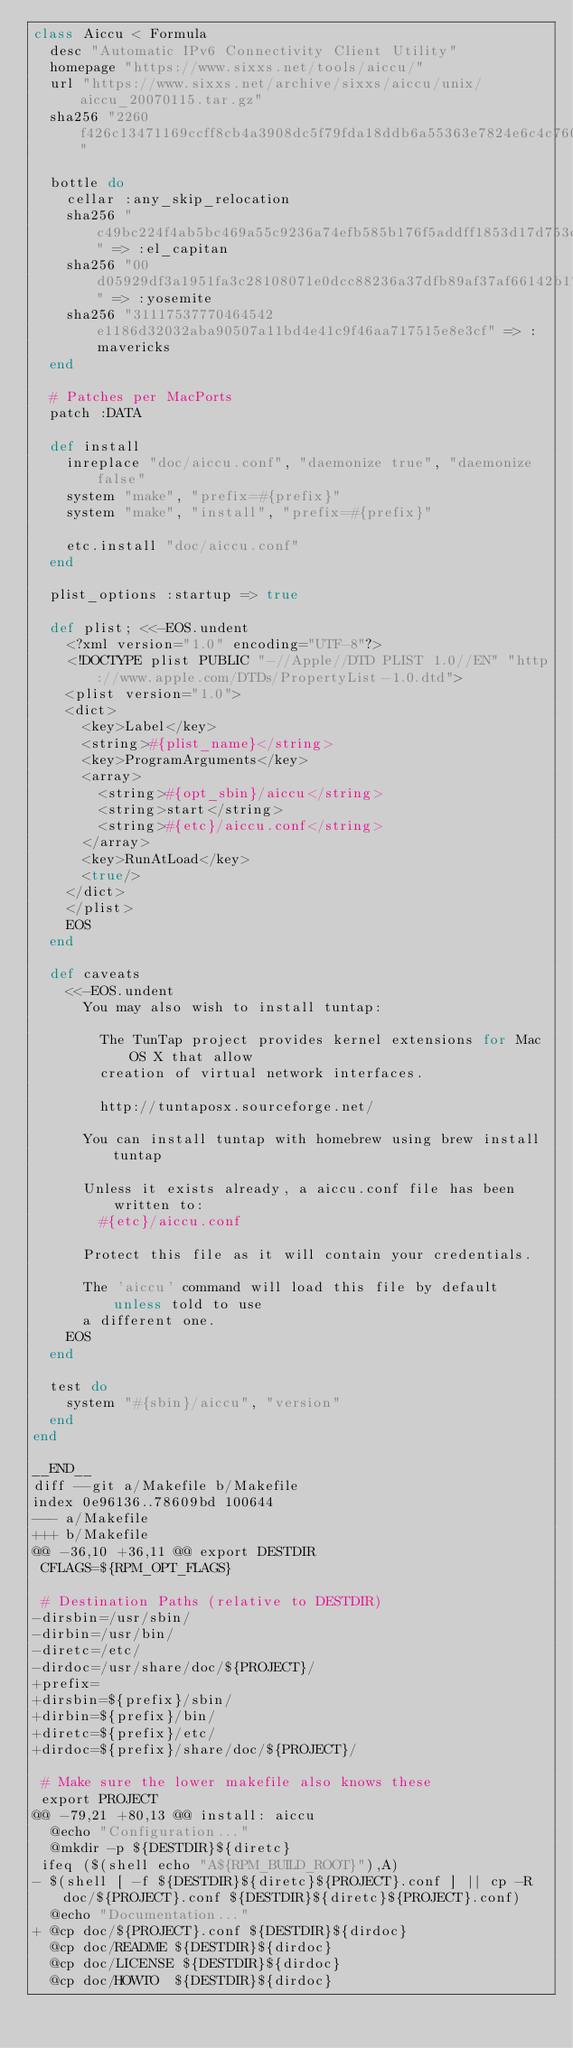<code> <loc_0><loc_0><loc_500><loc_500><_Ruby_>class Aiccu < Formula
  desc "Automatic IPv6 Connectivity Client Utility"
  homepage "https://www.sixxs.net/tools/aiccu/"
  url "https://www.sixxs.net/archive/sixxs/aiccu/unix/aiccu_20070115.tar.gz"
  sha256 "2260f426c13471169ccff8cb4a3908dc5f79fda18ddb6a55363e7824e6c4c760"

  bottle do
    cellar :any_skip_relocation
    sha256 "c49bc224f4ab5bc469a55c9236a74efb585b176f5addff1853d17d753cb3551c" => :el_capitan
    sha256 "00d05929df3a1951fa3c28108071e0dcc88236a37dfb89af37af66142b1746bf" => :yosemite
    sha256 "31117537770464542e1186d32032aba90507a11bd4e41c9f46aa717515e8e3cf" => :mavericks
  end

  # Patches per MacPorts
  patch :DATA

  def install
    inreplace "doc/aiccu.conf", "daemonize true", "daemonize false"
    system "make", "prefix=#{prefix}"
    system "make", "install", "prefix=#{prefix}"

    etc.install "doc/aiccu.conf"
  end

  plist_options :startup => true

  def plist; <<-EOS.undent
    <?xml version="1.0" encoding="UTF-8"?>
    <!DOCTYPE plist PUBLIC "-//Apple//DTD PLIST 1.0//EN" "http://www.apple.com/DTDs/PropertyList-1.0.dtd">
    <plist version="1.0">
    <dict>
      <key>Label</key>
      <string>#{plist_name}</string>
      <key>ProgramArguments</key>
      <array>
        <string>#{opt_sbin}/aiccu</string>
        <string>start</string>
        <string>#{etc}/aiccu.conf</string>
      </array>
      <key>RunAtLoad</key>
      <true/>
    </dict>
    </plist>
    EOS
  end

  def caveats
    <<-EOS.undent
      You may also wish to install tuntap:

        The TunTap project provides kernel extensions for Mac OS X that allow
        creation of virtual network interfaces.

        http://tuntaposx.sourceforge.net/

      You can install tuntap with homebrew using brew install tuntap

      Unless it exists already, a aiccu.conf file has been written to:
        #{etc}/aiccu.conf

      Protect this file as it will contain your credentials.

      The 'aiccu' command will load this file by default unless told to use
      a different one.
    EOS
  end

  test do
    system "#{sbin}/aiccu", "version"
  end
end

__END__
diff --git a/Makefile b/Makefile
index 0e96136..78609bd 100644
--- a/Makefile
+++ b/Makefile
@@ -36,10 +36,11 @@ export DESTDIR
 CFLAGS=${RPM_OPT_FLAGS}

 # Destination Paths (relative to DESTDIR)
-dirsbin=/usr/sbin/
-dirbin=/usr/bin/
-diretc=/etc/
-dirdoc=/usr/share/doc/${PROJECT}/
+prefix=
+dirsbin=${prefix}/sbin/
+dirbin=${prefix}/bin/
+diretc=${prefix}/etc/
+dirdoc=${prefix}/share/doc/${PROJECT}/

 # Make sure the lower makefile also knows these
 export PROJECT
@@ -79,21 +80,13 @@ install: aiccu
	@echo "Configuration..."
	@mkdir -p ${DESTDIR}${diretc}
 ifeq ($(shell echo "A${RPM_BUILD_ROOT}"),A)
-	$(shell [ -f ${DESTDIR}${diretc}${PROJECT}.conf ] || cp -R doc/${PROJECT}.conf ${DESTDIR}${diretc}${PROJECT}.conf)
	@echo "Documentation..."
+	@cp doc/${PROJECT}.conf ${DESTDIR}${dirdoc}
	@cp doc/README ${DESTDIR}${dirdoc}
	@cp doc/LICENSE ${DESTDIR}${dirdoc}
	@cp doc/HOWTO  ${DESTDIR}${dirdoc}</code> 